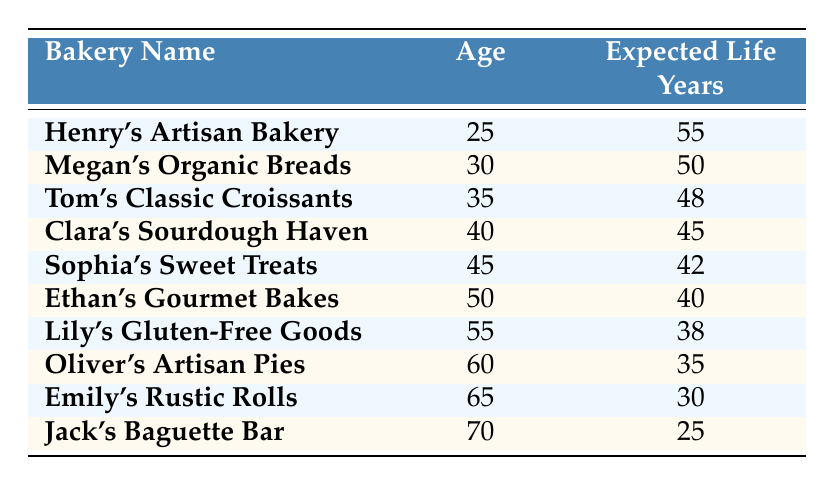What is the expected life years of Henry's Artisan Bakery? According to the table, Henry's Artisan Bakery is 25 years old and has an expected life of 55 years. Therefore, the expected life years for Henry's Artisan Bakery is directly specified in the table.
Answer: 55 What age is Sophia's Sweet Treats? In the table, it shows that Sophia's Sweet Treats is associated with the age of 45. This information is provided directly in the corresponding row of the table.
Answer: 45 Is the expected life years of Jack's Baguette Bar greater than 30? Looking at the table, Jack's Baguette Bar, which is 70 years old, has an expected life of 25 years. Since 25 is not greater than 30, the statement is false.
Answer: No What is the expected life years of the oldest baker? The oldest baker listed is Jack's Baguette Bar at the age of 70, with an expected life of 25 years. The expected life years for the oldest bakery can be directly found in the corresponding row.
Answer: 25 What is the average expected life years among bakers aged 50 and older? The bakers aged 50 and older are Ethan's Gourmet Bakes (40 years), Lily's Gluten-Free Goods (38 years), Oliver's Artisan Pies (35 years), Emily's Rustic Rolls (30 years), and Jack's Baguette Bar (25 years). The sum is 40 + 38 + 35 + 30 + 25 = 168. There are 5 bakers, so the average is 168/5 = 33.6, which can be rounded to 34 for simplicity.
Answer: 34 Who is the youngest artisan baker and what is their expected life years? The youngest artisan baker is Henry's Artisan Bakery at age 25, with an expected life of 55 years. This information can be found in the first row of the table.
Answer: 55 